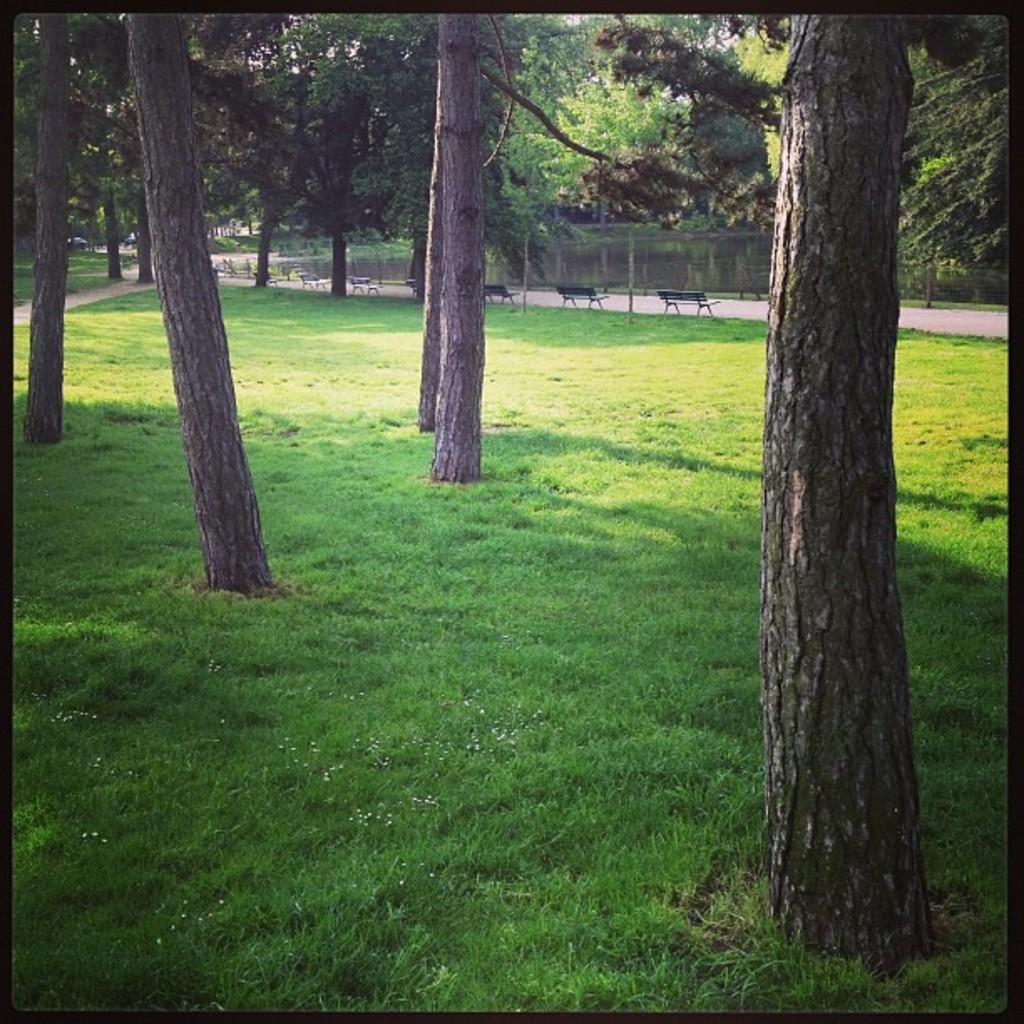What type of vegetation can be seen in the foreground of the image? There is grass and trees in the foreground of the image. What type of seating is visible in the background of the image? There are benches in the background of the image. What type of vegetation can be seen in the background of the image? There are trees in the background of the image. What type of barrier is present in the background of the image? There is fencing in the background of the image. What natural feature can be seen in the background of the image? There is water visible in the background of the image. What type of vest is being worn by the tree in the foreground of the image? There are no vests present in the image, as trees do not wear clothing. How many sponges are floating in the water visible in the background of the image? There are no sponges visible in the image, as the water feature is not described in detail. 